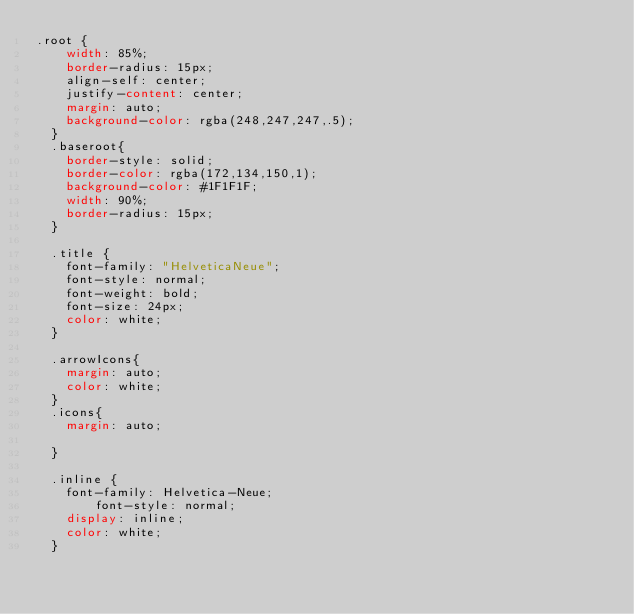Convert code to text. <code><loc_0><loc_0><loc_500><loc_500><_CSS_>.root {
    width: 85%;
    border-radius: 15px;
    align-self: center;
    justify-content: center;
    margin: auto;
    background-color: rgba(248,247,247,.5);
  }
  .baseroot{
    border-style: solid;
    border-color: rgba(172,134,150,1);
    background-color: #1F1F1F;
    width: 90%;
    border-radius: 15px;
  }

  .title {
    font-family: "HelveticaNeue";
    font-style: normal;
    font-weight: bold;
    font-size: 24px;
    color: white;
  }

  .arrowIcons{
    margin: auto;
    color: white;
  }
  .icons{
    margin: auto;

  }

  .inline {
    font-family: Helvetica-Neue;
		font-style: normal;
    display: inline;
    color: white;
  }</code> 